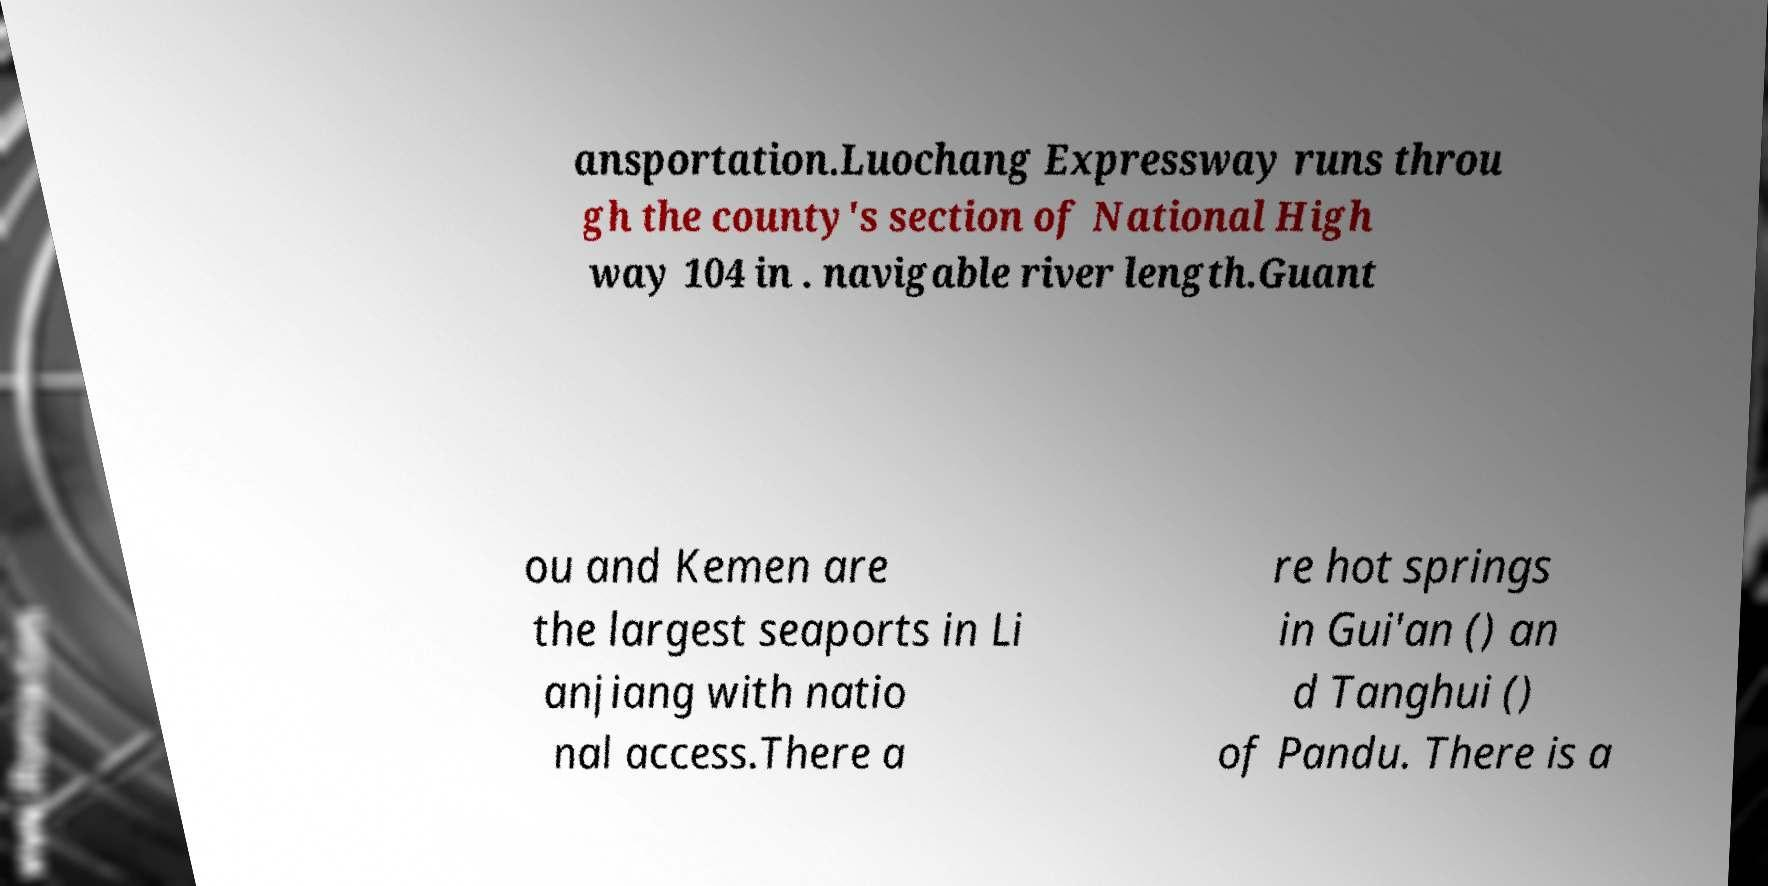Can you read and provide the text displayed in the image?This photo seems to have some interesting text. Can you extract and type it out for me? ansportation.Luochang Expressway runs throu gh the county's section of National High way 104 in . navigable river length.Guant ou and Kemen are the largest seaports in Li anjiang with natio nal access.There a re hot springs in Gui'an () an d Tanghui () of Pandu. There is a 